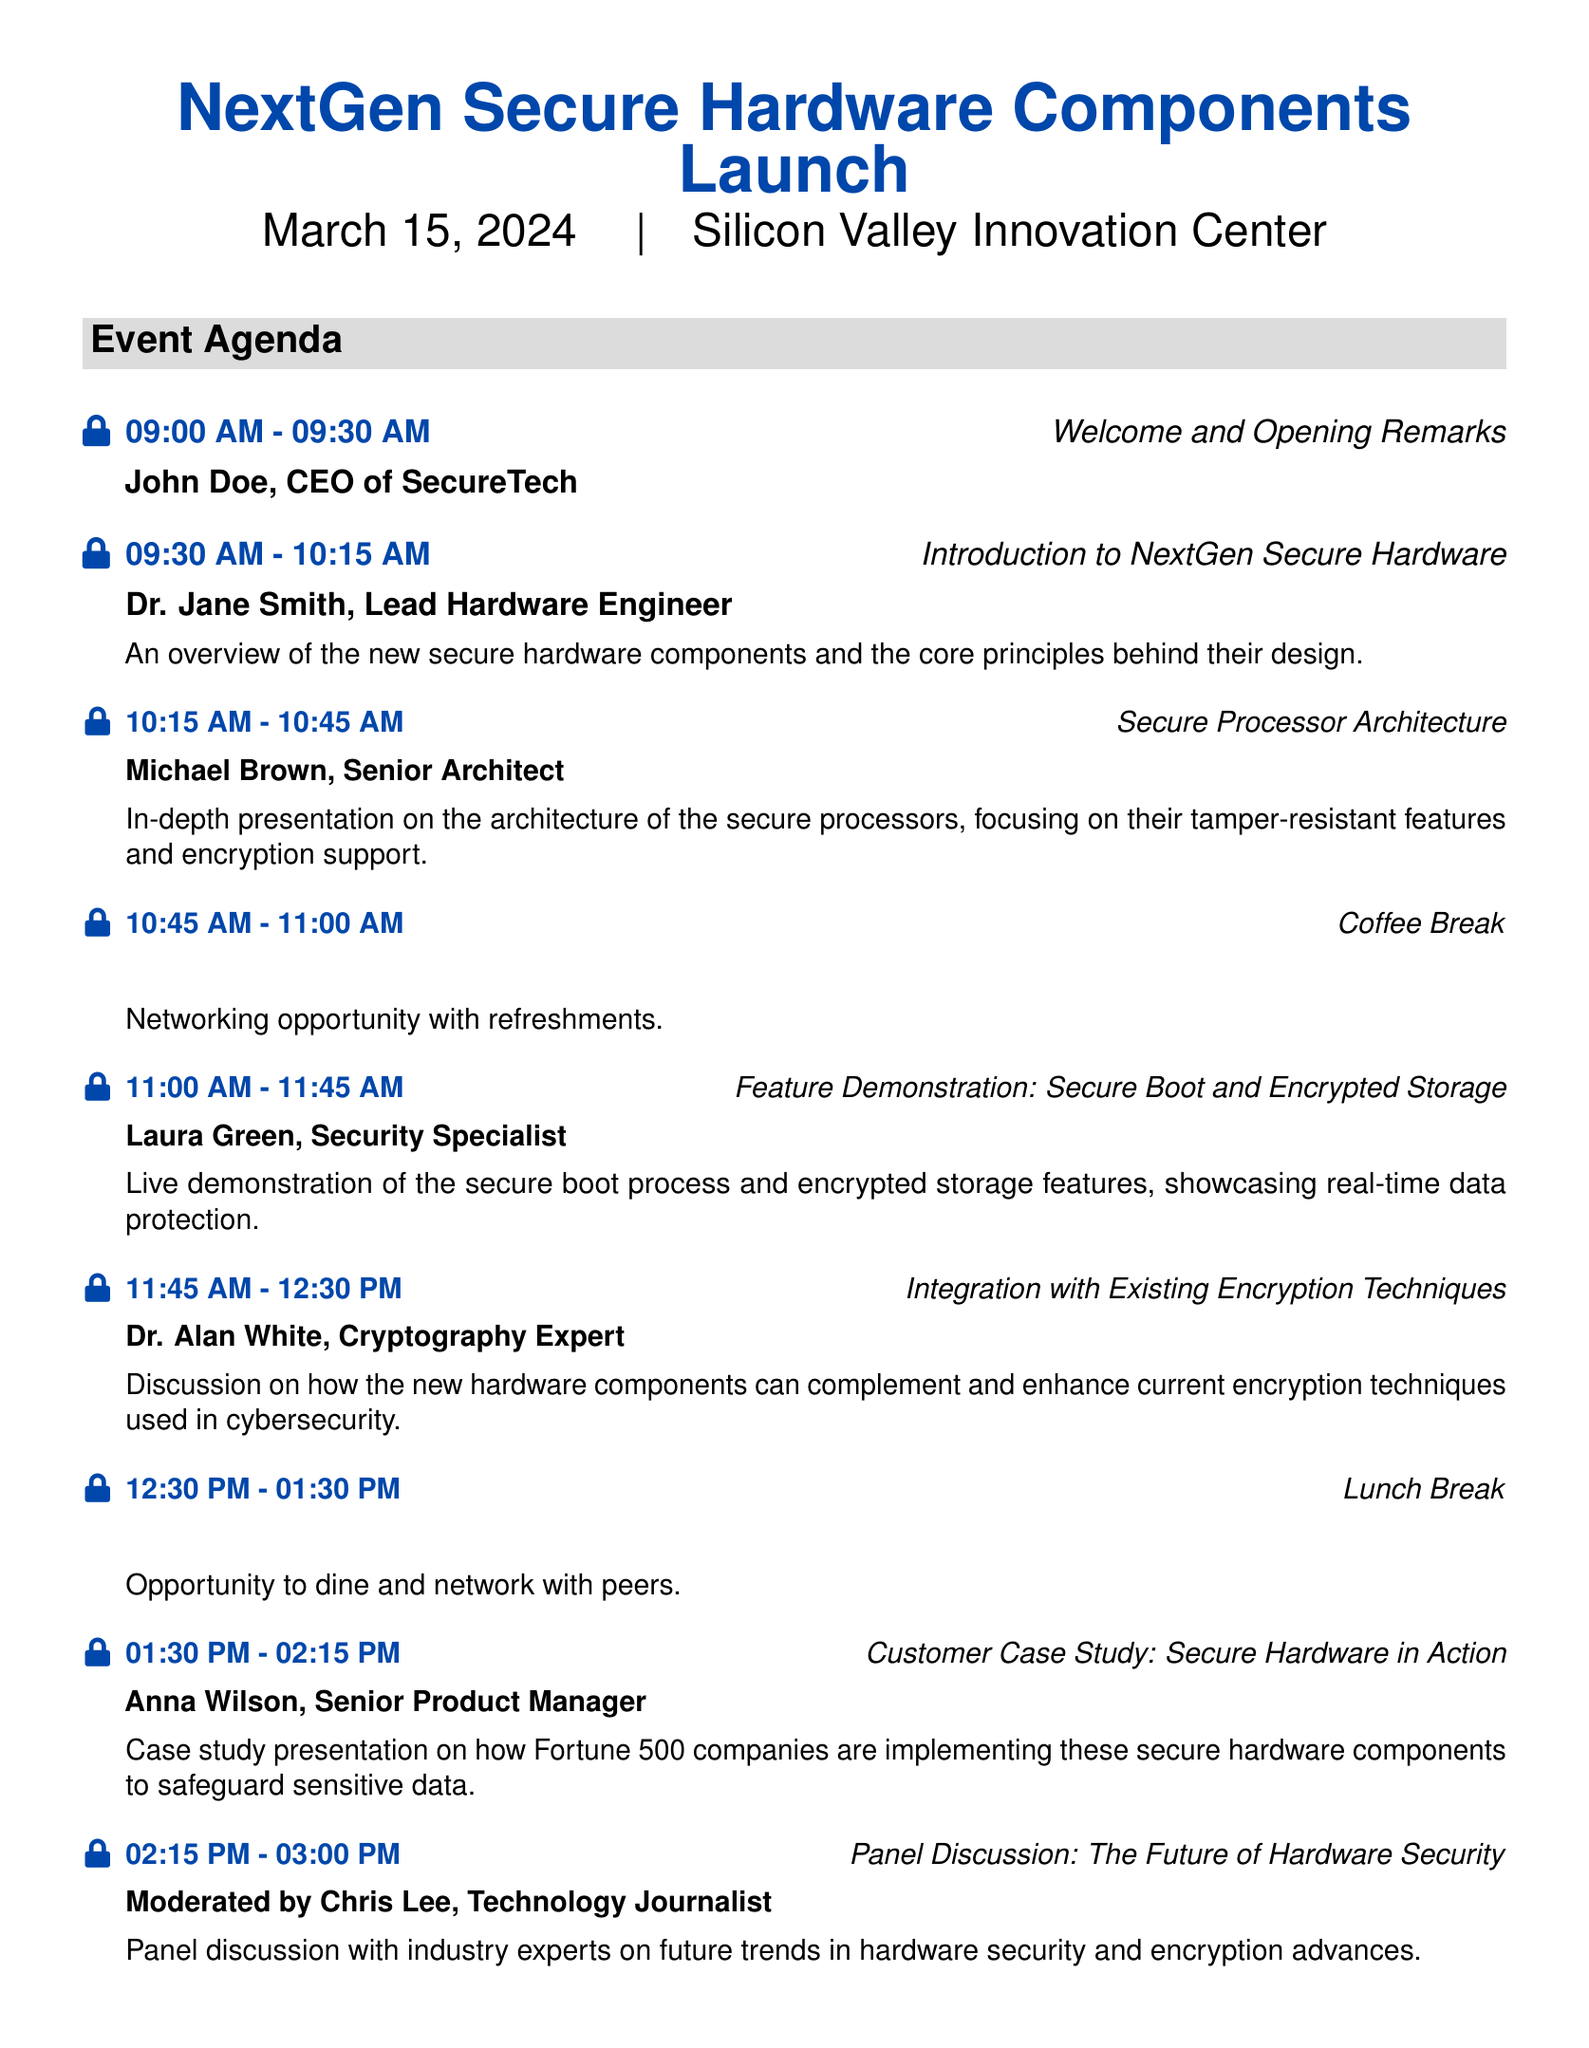What is the date of the event? The date is specified in the document as March 15, 2024.
Answer: March 15, 2024 Who is giving the opening remarks? The document lists John Doe as the CEO of SecureTech, who is giving the opening remarks.
Answer: John Doe, CEO of SecureTech What time does the secure boot demonstration start? The event agenda states that the feature demonstration starts at 11:00 AM.
Answer: 11:00 AM What is the topic of Dr. Alan White's presentation? The agenda mentions that Dr. Alan White will discuss the integration of the new hardware components with existing encryption techniques.
Answer: Integration with Existing Encryption Techniques How long is the coffee break? According to the document, the coffee break is scheduled for 15 minutes from 10:45 AM to 11:00 AM.
Answer: 15 minutes What type of session follows the afternoon refreshments? The event agenda lists an interactive question and answer session immediately after the afternoon refreshments.
Answer: Q&A Session Who moderates the panel discussion? Chris Lee is identified as the Technology Journalist moderating the panel discussion.
Answer: Chris Lee, Technology Journalist What is emphasized with the tagline at the bottom of the document? The tagline highlights the mission of enhancing security with hardware components, emphasizing the importance of security.
Answer: Securing the Future, One Component at a Time 